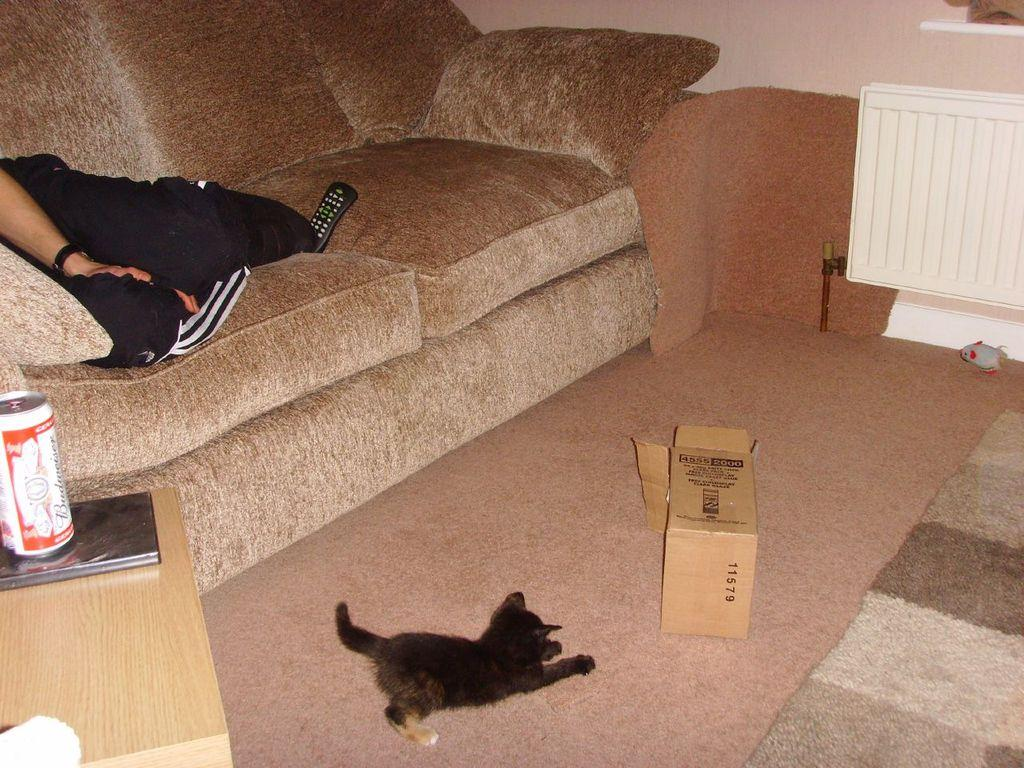What is the person doing in the image? The person is sitting on the sofa. What is the surface beneath the person and other objects in the image? There is a floor in the image. What object can be seen in the image that is typically used for storage or packaging? There is a box in the image. What type of animal is present in the image? There is a dog in the image. What piece of furniture is visible in the image that is often used for placing items? There is a table in the image. What is on top of the table in the image? There is a tin on the table. How many apples are on the table in the image? There are no apples present in the image; only a tin is on the table. What type of control is being used by the person in the image? There is no control device visible in the image; the person is simply sitting on the sofa. 